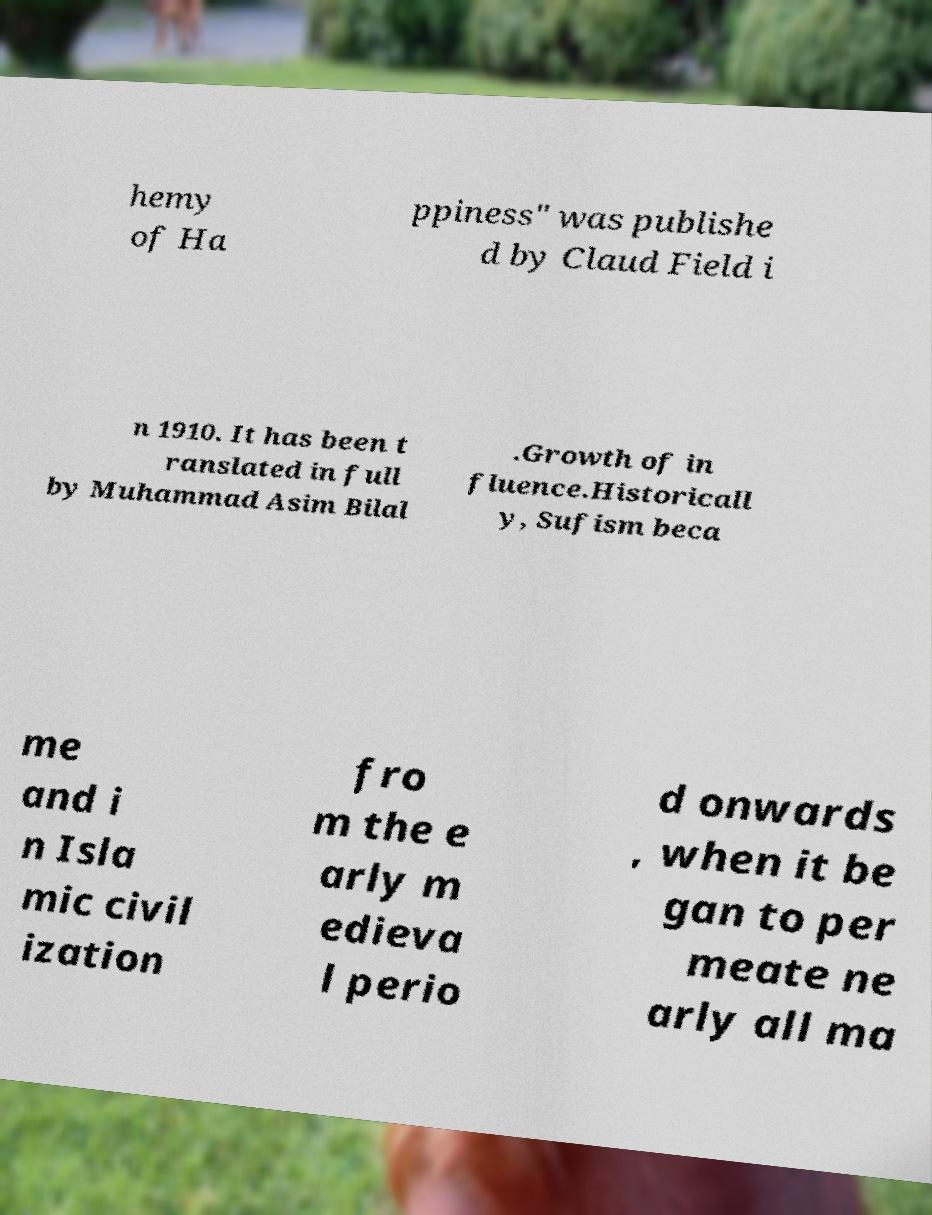Can you read and provide the text displayed in the image?This photo seems to have some interesting text. Can you extract and type it out for me? hemy of Ha ppiness" was publishe d by Claud Field i n 1910. It has been t ranslated in full by Muhammad Asim Bilal .Growth of in fluence.Historicall y, Sufism beca me and i n Isla mic civil ization fro m the e arly m edieva l perio d onwards , when it be gan to per meate ne arly all ma 